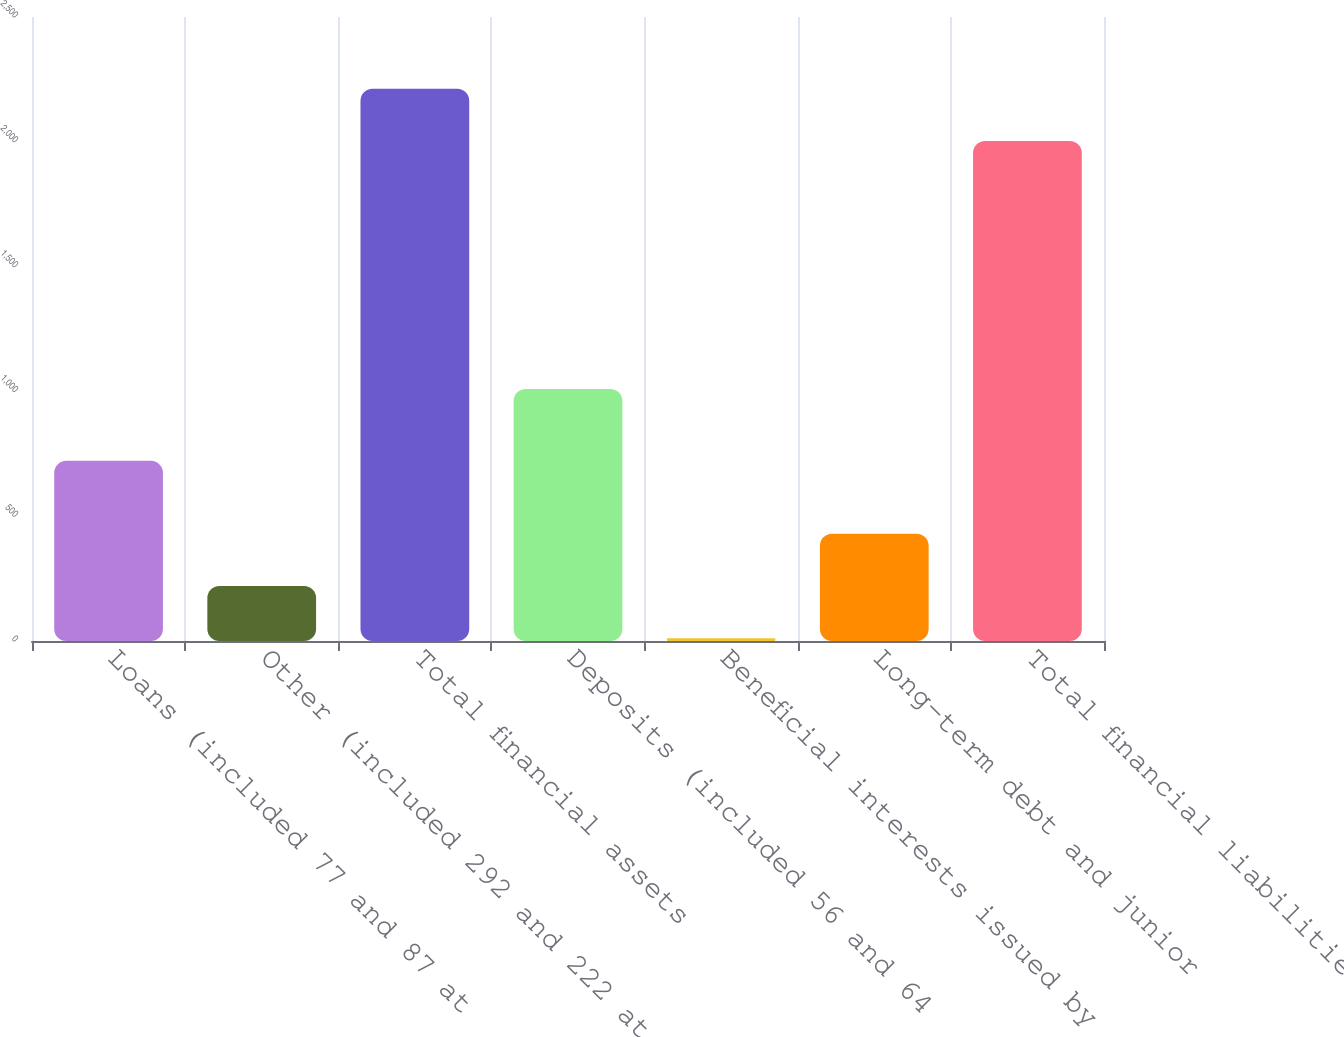Convert chart to OTSL. <chart><loc_0><loc_0><loc_500><loc_500><bar_chart><fcel>Loans (included 77 and 87 at<fcel>Other (included 292 and 222 at<fcel>Total financial assets<fcel>Deposits (included 56 and 64<fcel>Beneficial interests issued by<fcel>Long-term debt and junior<fcel>Total financial liabilities<nl><fcel>721.7<fcel>220.01<fcel>2212.91<fcel>1009.3<fcel>10.6<fcel>429.42<fcel>2003.5<nl></chart> 